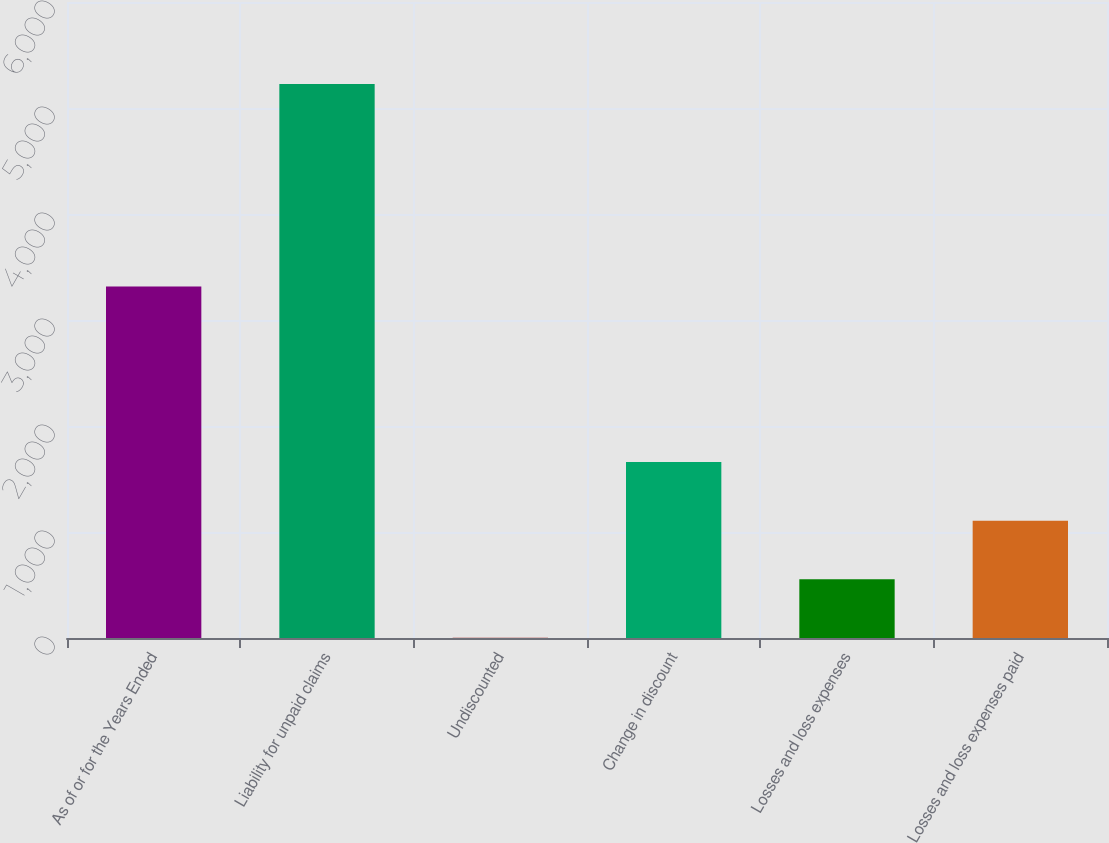Convert chart to OTSL. <chart><loc_0><loc_0><loc_500><loc_500><bar_chart><fcel>As of or for the Years Ended<fcel>Liability for unpaid claims<fcel>Undiscounted<fcel>Change in discount<fcel>Losses and loss expenses<fcel>Losses and loss expenses paid<nl><fcel>3316.4<fcel>5226<fcel>2<fcel>1659.2<fcel>554.4<fcel>1106.8<nl></chart> 